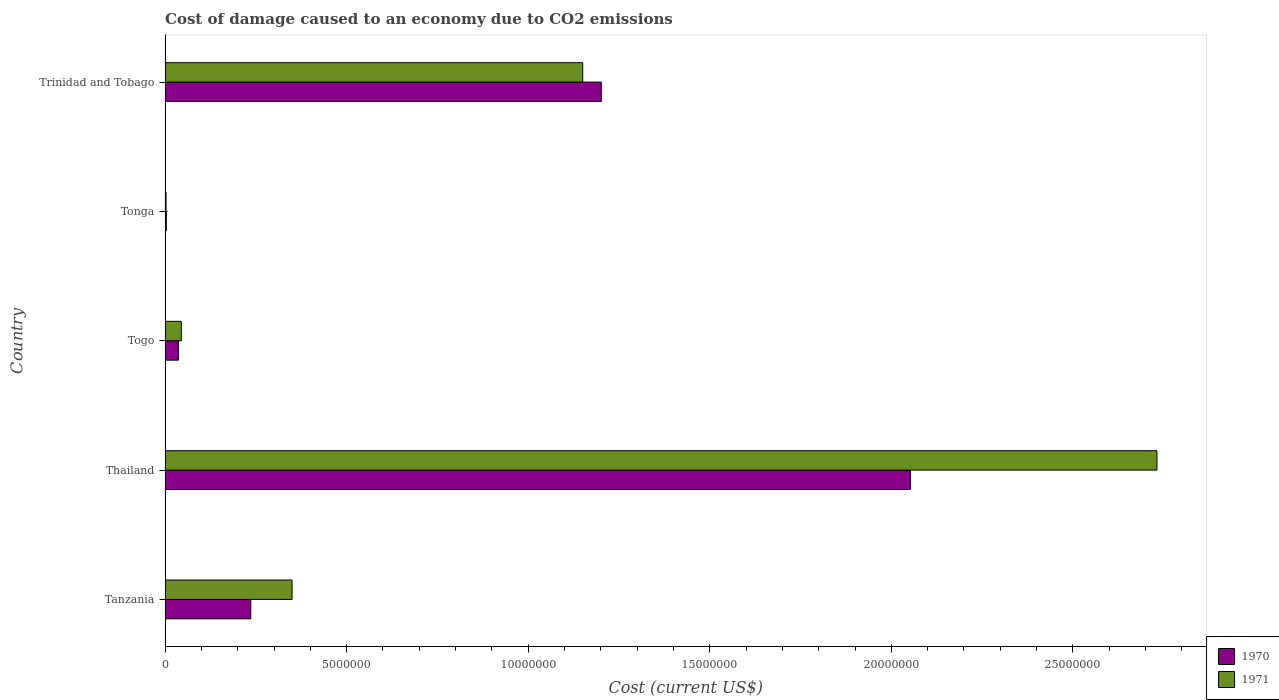How many groups of bars are there?
Your response must be concise. 5. Are the number of bars on each tick of the Y-axis equal?
Keep it short and to the point. Yes. What is the label of the 3rd group of bars from the top?
Ensure brevity in your answer.  Togo. What is the cost of damage caused due to CO2 emissisons in 1971 in Trinidad and Tobago?
Make the answer very short. 1.15e+07. Across all countries, what is the maximum cost of damage caused due to CO2 emissisons in 1971?
Provide a succinct answer. 2.73e+07. Across all countries, what is the minimum cost of damage caused due to CO2 emissisons in 1970?
Make the answer very short. 3.43e+04. In which country was the cost of damage caused due to CO2 emissisons in 1971 maximum?
Keep it short and to the point. Thailand. In which country was the cost of damage caused due to CO2 emissisons in 1970 minimum?
Provide a short and direct response. Tonga. What is the total cost of damage caused due to CO2 emissisons in 1971 in the graph?
Ensure brevity in your answer.  4.28e+07. What is the difference between the cost of damage caused due to CO2 emissisons in 1971 in Togo and that in Trinidad and Tobago?
Your answer should be compact. -1.11e+07. What is the difference between the cost of damage caused due to CO2 emissisons in 1971 in Thailand and the cost of damage caused due to CO2 emissisons in 1970 in Togo?
Ensure brevity in your answer.  2.69e+07. What is the average cost of damage caused due to CO2 emissisons in 1971 per country?
Provide a short and direct response. 8.56e+06. What is the difference between the cost of damage caused due to CO2 emissisons in 1970 and cost of damage caused due to CO2 emissisons in 1971 in Togo?
Offer a very short reply. -8.04e+04. What is the ratio of the cost of damage caused due to CO2 emissisons in 1970 in Togo to that in Trinidad and Tobago?
Provide a short and direct response. 0.03. Is the difference between the cost of damage caused due to CO2 emissisons in 1970 in Tanzania and Togo greater than the difference between the cost of damage caused due to CO2 emissisons in 1971 in Tanzania and Togo?
Give a very brief answer. No. What is the difference between the highest and the second highest cost of damage caused due to CO2 emissisons in 1971?
Provide a short and direct response. 1.58e+07. What is the difference between the highest and the lowest cost of damage caused due to CO2 emissisons in 1971?
Offer a terse response. 2.73e+07. In how many countries, is the cost of damage caused due to CO2 emissisons in 1970 greater than the average cost of damage caused due to CO2 emissisons in 1970 taken over all countries?
Ensure brevity in your answer.  2. What does the 2nd bar from the top in Trinidad and Tobago represents?
Offer a terse response. 1970. What does the 2nd bar from the bottom in Thailand represents?
Keep it short and to the point. 1971. Are all the bars in the graph horizontal?
Offer a terse response. Yes. Does the graph contain any zero values?
Offer a very short reply. No. Does the graph contain grids?
Offer a very short reply. No. How many legend labels are there?
Provide a short and direct response. 2. What is the title of the graph?
Your answer should be very brief. Cost of damage caused to an economy due to CO2 emissions. What is the label or title of the X-axis?
Your answer should be very brief. Cost (current US$). What is the label or title of the Y-axis?
Offer a very short reply. Country. What is the Cost (current US$) of 1970 in Tanzania?
Make the answer very short. 2.36e+06. What is the Cost (current US$) of 1971 in Tanzania?
Provide a succinct answer. 3.50e+06. What is the Cost (current US$) in 1970 in Thailand?
Give a very brief answer. 2.05e+07. What is the Cost (current US$) of 1971 in Thailand?
Offer a very short reply. 2.73e+07. What is the Cost (current US$) in 1970 in Togo?
Provide a short and direct response. 3.67e+05. What is the Cost (current US$) of 1971 in Togo?
Make the answer very short. 4.48e+05. What is the Cost (current US$) in 1970 in Tonga?
Provide a succinct answer. 3.43e+04. What is the Cost (current US$) of 1971 in Tonga?
Give a very brief answer. 2.60e+04. What is the Cost (current US$) in 1970 in Trinidad and Tobago?
Keep it short and to the point. 1.20e+07. What is the Cost (current US$) of 1971 in Trinidad and Tobago?
Keep it short and to the point. 1.15e+07. Across all countries, what is the maximum Cost (current US$) in 1970?
Your answer should be compact. 2.05e+07. Across all countries, what is the maximum Cost (current US$) in 1971?
Make the answer very short. 2.73e+07. Across all countries, what is the minimum Cost (current US$) in 1970?
Your answer should be very brief. 3.43e+04. Across all countries, what is the minimum Cost (current US$) of 1971?
Your answer should be compact. 2.60e+04. What is the total Cost (current US$) of 1970 in the graph?
Offer a very short reply. 3.53e+07. What is the total Cost (current US$) in 1971 in the graph?
Ensure brevity in your answer.  4.28e+07. What is the difference between the Cost (current US$) of 1970 in Tanzania and that in Thailand?
Give a very brief answer. -1.82e+07. What is the difference between the Cost (current US$) of 1971 in Tanzania and that in Thailand?
Ensure brevity in your answer.  -2.38e+07. What is the difference between the Cost (current US$) in 1970 in Tanzania and that in Togo?
Keep it short and to the point. 1.99e+06. What is the difference between the Cost (current US$) in 1971 in Tanzania and that in Togo?
Provide a short and direct response. 3.05e+06. What is the difference between the Cost (current US$) of 1970 in Tanzania and that in Tonga?
Your response must be concise. 2.32e+06. What is the difference between the Cost (current US$) of 1971 in Tanzania and that in Tonga?
Provide a short and direct response. 3.47e+06. What is the difference between the Cost (current US$) of 1970 in Tanzania and that in Trinidad and Tobago?
Provide a succinct answer. -9.65e+06. What is the difference between the Cost (current US$) of 1971 in Tanzania and that in Trinidad and Tobago?
Give a very brief answer. -8.00e+06. What is the difference between the Cost (current US$) of 1970 in Thailand and that in Togo?
Your answer should be compact. 2.02e+07. What is the difference between the Cost (current US$) in 1971 in Thailand and that in Togo?
Provide a short and direct response. 2.69e+07. What is the difference between the Cost (current US$) of 1970 in Thailand and that in Tonga?
Offer a terse response. 2.05e+07. What is the difference between the Cost (current US$) of 1971 in Thailand and that in Tonga?
Provide a succinct answer. 2.73e+07. What is the difference between the Cost (current US$) of 1970 in Thailand and that in Trinidad and Tobago?
Your answer should be very brief. 8.51e+06. What is the difference between the Cost (current US$) of 1971 in Thailand and that in Trinidad and Tobago?
Your answer should be very brief. 1.58e+07. What is the difference between the Cost (current US$) in 1970 in Togo and that in Tonga?
Your answer should be compact. 3.33e+05. What is the difference between the Cost (current US$) in 1971 in Togo and that in Tonga?
Your answer should be compact. 4.21e+05. What is the difference between the Cost (current US$) of 1970 in Togo and that in Trinidad and Tobago?
Provide a succinct answer. -1.16e+07. What is the difference between the Cost (current US$) of 1971 in Togo and that in Trinidad and Tobago?
Offer a very short reply. -1.11e+07. What is the difference between the Cost (current US$) in 1970 in Tonga and that in Trinidad and Tobago?
Provide a succinct answer. -1.20e+07. What is the difference between the Cost (current US$) in 1971 in Tonga and that in Trinidad and Tobago?
Give a very brief answer. -1.15e+07. What is the difference between the Cost (current US$) in 1970 in Tanzania and the Cost (current US$) in 1971 in Thailand?
Your response must be concise. -2.50e+07. What is the difference between the Cost (current US$) in 1970 in Tanzania and the Cost (current US$) in 1971 in Togo?
Give a very brief answer. 1.91e+06. What is the difference between the Cost (current US$) of 1970 in Tanzania and the Cost (current US$) of 1971 in Tonga?
Make the answer very short. 2.33e+06. What is the difference between the Cost (current US$) of 1970 in Tanzania and the Cost (current US$) of 1971 in Trinidad and Tobago?
Keep it short and to the point. -9.14e+06. What is the difference between the Cost (current US$) in 1970 in Thailand and the Cost (current US$) in 1971 in Togo?
Your answer should be very brief. 2.01e+07. What is the difference between the Cost (current US$) of 1970 in Thailand and the Cost (current US$) of 1971 in Tonga?
Keep it short and to the point. 2.05e+07. What is the difference between the Cost (current US$) of 1970 in Thailand and the Cost (current US$) of 1971 in Trinidad and Tobago?
Ensure brevity in your answer.  9.02e+06. What is the difference between the Cost (current US$) in 1970 in Togo and the Cost (current US$) in 1971 in Tonga?
Your answer should be compact. 3.41e+05. What is the difference between the Cost (current US$) of 1970 in Togo and the Cost (current US$) of 1971 in Trinidad and Tobago?
Offer a very short reply. -1.11e+07. What is the difference between the Cost (current US$) of 1970 in Tonga and the Cost (current US$) of 1971 in Trinidad and Tobago?
Give a very brief answer. -1.15e+07. What is the average Cost (current US$) in 1970 per country?
Make the answer very short. 7.06e+06. What is the average Cost (current US$) of 1971 per country?
Make the answer very short. 8.56e+06. What is the difference between the Cost (current US$) in 1970 and Cost (current US$) in 1971 in Tanzania?
Make the answer very short. -1.14e+06. What is the difference between the Cost (current US$) in 1970 and Cost (current US$) in 1971 in Thailand?
Your response must be concise. -6.79e+06. What is the difference between the Cost (current US$) in 1970 and Cost (current US$) in 1971 in Togo?
Your answer should be very brief. -8.04e+04. What is the difference between the Cost (current US$) in 1970 and Cost (current US$) in 1971 in Tonga?
Make the answer very short. 8244.44. What is the difference between the Cost (current US$) in 1970 and Cost (current US$) in 1971 in Trinidad and Tobago?
Keep it short and to the point. 5.11e+05. What is the ratio of the Cost (current US$) in 1970 in Tanzania to that in Thailand?
Make the answer very short. 0.12. What is the ratio of the Cost (current US$) of 1971 in Tanzania to that in Thailand?
Offer a terse response. 0.13. What is the ratio of the Cost (current US$) in 1970 in Tanzania to that in Togo?
Your answer should be compact. 6.43. What is the ratio of the Cost (current US$) of 1971 in Tanzania to that in Togo?
Offer a very short reply. 7.81. What is the ratio of the Cost (current US$) in 1970 in Tanzania to that in Tonga?
Offer a very short reply. 68.86. What is the ratio of the Cost (current US$) in 1971 in Tanzania to that in Tonga?
Provide a succinct answer. 134.4. What is the ratio of the Cost (current US$) of 1970 in Tanzania to that in Trinidad and Tobago?
Keep it short and to the point. 0.2. What is the ratio of the Cost (current US$) of 1971 in Tanzania to that in Trinidad and Tobago?
Provide a short and direct response. 0.3. What is the ratio of the Cost (current US$) in 1970 in Thailand to that in Togo?
Keep it short and to the point. 55.91. What is the ratio of the Cost (current US$) in 1971 in Thailand to that in Togo?
Your response must be concise. 61.03. What is the ratio of the Cost (current US$) of 1970 in Thailand to that in Tonga?
Make the answer very short. 599. What is the ratio of the Cost (current US$) in 1971 in Thailand to that in Tonga?
Give a very brief answer. 1049.8. What is the ratio of the Cost (current US$) in 1970 in Thailand to that in Trinidad and Tobago?
Provide a short and direct response. 1.71. What is the ratio of the Cost (current US$) of 1971 in Thailand to that in Trinidad and Tobago?
Your answer should be compact. 2.38. What is the ratio of the Cost (current US$) in 1970 in Togo to that in Tonga?
Make the answer very short. 10.71. What is the ratio of the Cost (current US$) of 1971 in Togo to that in Tonga?
Offer a very short reply. 17.2. What is the ratio of the Cost (current US$) of 1970 in Togo to that in Trinidad and Tobago?
Make the answer very short. 0.03. What is the ratio of the Cost (current US$) of 1971 in Togo to that in Trinidad and Tobago?
Provide a short and direct response. 0.04. What is the ratio of the Cost (current US$) of 1970 in Tonga to that in Trinidad and Tobago?
Provide a succinct answer. 0. What is the ratio of the Cost (current US$) of 1971 in Tonga to that in Trinidad and Tobago?
Give a very brief answer. 0. What is the difference between the highest and the second highest Cost (current US$) of 1970?
Provide a succinct answer. 8.51e+06. What is the difference between the highest and the second highest Cost (current US$) in 1971?
Your response must be concise. 1.58e+07. What is the difference between the highest and the lowest Cost (current US$) in 1970?
Make the answer very short. 2.05e+07. What is the difference between the highest and the lowest Cost (current US$) of 1971?
Make the answer very short. 2.73e+07. 